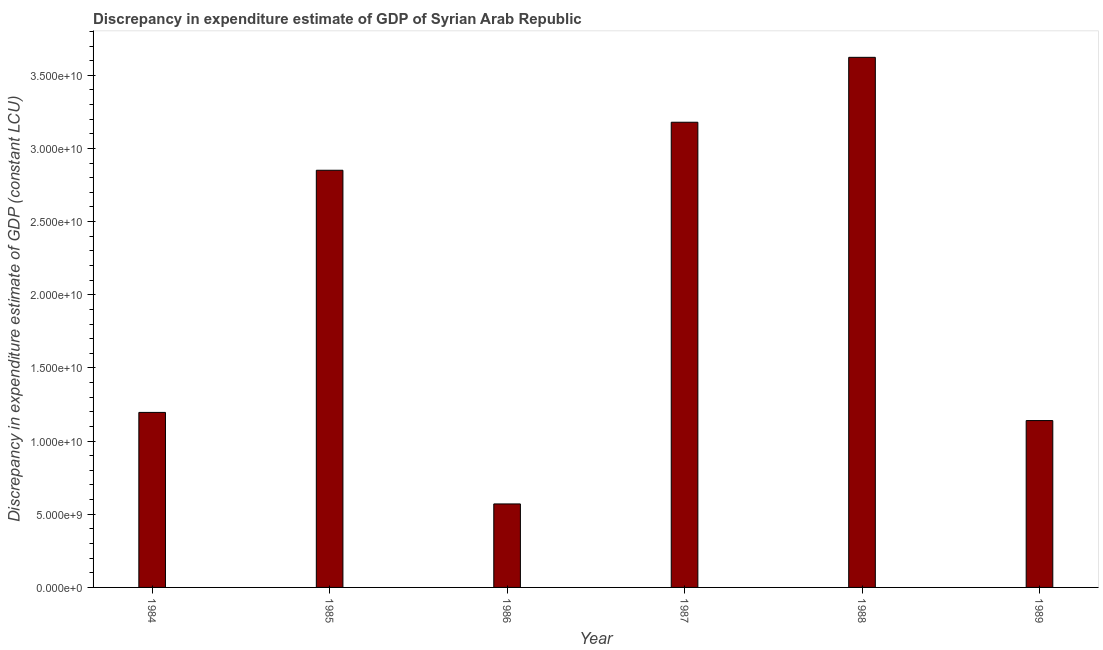Does the graph contain any zero values?
Ensure brevity in your answer.  No. Does the graph contain grids?
Your response must be concise. No. What is the title of the graph?
Ensure brevity in your answer.  Discrepancy in expenditure estimate of GDP of Syrian Arab Republic. What is the label or title of the X-axis?
Make the answer very short. Year. What is the label or title of the Y-axis?
Provide a succinct answer. Discrepancy in expenditure estimate of GDP (constant LCU). What is the discrepancy in expenditure estimate of gdp in 1987?
Your response must be concise. 3.18e+1. Across all years, what is the maximum discrepancy in expenditure estimate of gdp?
Offer a very short reply. 3.62e+1. Across all years, what is the minimum discrepancy in expenditure estimate of gdp?
Provide a short and direct response. 5.71e+09. In which year was the discrepancy in expenditure estimate of gdp minimum?
Keep it short and to the point. 1986. What is the sum of the discrepancy in expenditure estimate of gdp?
Provide a short and direct response. 1.26e+11. What is the difference between the discrepancy in expenditure estimate of gdp in 1987 and 1988?
Provide a short and direct response. -4.44e+09. What is the average discrepancy in expenditure estimate of gdp per year?
Your response must be concise. 2.09e+1. What is the median discrepancy in expenditure estimate of gdp?
Provide a short and direct response. 2.02e+1. In how many years, is the discrepancy in expenditure estimate of gdp greater than 30000000000 LCU?
Offer a very short reply. 2. Do a majority of the years between 1986 and 1987 (inclusive) have discrepancy in expenditure estimate of gdp greater than 3000000000 LCU?
Offer a very short reply. Yes. Is the discrepancy in expenditure estimate of gdp in 1987 less than that in 1989?
Keep it short and to the point. No. What is the difference between the highest and the second highest discrepancy in expenditure estimate of gdp?
Provide a succinct answer. 4.44e+09. What is the difference between the highest and the lowest discrepancy in expenditure estimate of gdp?
Keep it short and to the point. 3.05e+1. How many bars are there?
Your response must be concise. 6. Are all the bars in the graph horizontal?
Your response must be concise. No. What is the difference between two consecutive major ticks on the Y-axis?
Offer a very short reply. 5.00e+09. What is the Discrepancy in expenditure estimate of GDP (constant LCU) in 1984?
Your response must be concise. 1.20e+1. What is the Discrepancy in expenditure estimate of GDP (constant LCU) of 1985?
Provide a succinct answer. 2.85e+1. What is the Discrepancy in expenditure estimate of GDP (constant LCU) of 1986?
Make the answer very short. 5.71e+09. What is the Discrepancy in expenditure estimate of GDP (constant LCU) in 1987?
Offer a very short reply. 3.18e+1. What is the Discrepancy in expenditure estimate of GDP (constant LCU) of 1988?
Offer a very short reply. 3.62e+1. What is the Discrepancy in expenditure estimate of GDP (constant LCU) in 1989?
Provide a short and direct response. 1.14e+1. What is the difference between the Discrepancy in expenditure estimate of GDP (constant LCU) in 1984 and 1985?
Make the answer very short. -1.65e+1. What is the difference between the Discrepancy in expenditure estimate of GDP (constant LCU) in 1984 and 1986?
Make the answer very short. 6.25e+09. What is the difference between the Discrepancy in expenditure estimate of GDP (constant LCU) in 1984 and 1987?
Ensure brevity in your answer.  -1.98e+1. What is the difference between the Discrepancy in expenditure estimate of GDP (constant LCU) in 1984 and 1988?
Provide a short and direct response. -2.43e+1. What is the difference between the Discrepancy in expenditure estimate of GDP (constant LCU) in 1984 and 1989?
Your answer should be compact. 5.57e+08. What is the difference between the Discrepancy in expenditure estimate of GDP (constant LCU) in 1985 and 1986?
Give a very brief answer. 2.28e+1. What is the difference between the Discrepancy in expenditure estimate of GDP (constant LCU) in 1985 and 1987?
Keep it short and to the point. -3.28e+09. What is the difference between the Discrepancy in expenditure estimate of GDP (constant LCU) in 1985 and 1988?
Provide a succinct answer. -7.72e+09. What is the difference between the Discrepancy in expenditure estimate of GDP (constant LCU) in 1985 and 1989?
Give a very brief answer. 1.71e+1. What is the difference between the Discrepancy in expenditure estimate of GDP (constant LCU) in 1986 and 1987?
Make the answer very short. -2.61e+1. What is the difference between the Discrepancy in expenditure estimate of GDP (constant LCU) in 1986 and 1988?
Your answer should be compact. -3.05e+1. What is the difference between the Discrepancy in expenditure estimate of GDP (constant LCU) in 1986 and 1989?
Give a very brief answer. -5.70e+09. What is the difference between the Discrepancy in expenditure estimate of GDP (constant LCU) in 1987 and 1988?
Offer a terse response. -4.44e+09. What is the difference between the Discrepancy in expenditure estimate of GDP (constant LCU) in 1987 and 1989?
Provide a short and direct response. 2.04e+1. What is the difference between the Discrepancy in expenditure estimate of GDP (constant LCU) in 1988 and 1989?
Keep it short and to the point. 2.48e+1. What is the ratio of the Discrepancy in expenditure estimate of GDP (constant LCU) in 1984 to that in 1985?
Offer a terse response. 0.42. What is the ratio of the Discrepancy in expenditure estimate of GDP (constant LCU) in 1984 to that in 1986?
Offer a terse response. 2.1. What is the ratio of the Discrepancy in expenditure estimate of GDP (constant LCU) in 1984 to that in 1987?
Keep it short and to the point. 0.38. What is the ratio of the Discrepancy in expenditure estimate of GDP (constant LCU) in 1984 to that in 1988?
Your answer should be compact. 0.33. What is the ratio of the Discrepancy in expenditure estimate of GDP (constant LCU) in 1984 to that in 1989?
Keep it short and to the point. 1.05. What is the ratio of the Discrepancy in expenditure estimate of GDP (constant LCU) in 1985 to that in 1986?
Provide a succinct answer. 5. What is the ratio of the Discrepancy in expenditure estimate of GDP (constant LCU) in 1985 to that in 1987?
Offer a very short reply. 0.9. What is the ratio of the Discrepancy in expenditure estimate of GDP (constant LCU) in 1985 to that in 1988?
Make the answer very short. 0.79. What is the ratio of the Discrepancy in expenditure estimate of GDP (constant LCU) in 1986 to that in 1987?
Make the answer very short. 0.18. What is the ratio of the Discrepancy in expenditure estimate of GDP (constant LCU) in 1986 to that in 1988?
Offer a terse response. 0.16. What is the ratio of the Discrepancy in expenditure estimate of GDP (constant LCU) in 1986 to that in 1989?
Offer a terse response. 0.5. What is the ratio of the Discrepancy in expenditure estimate of GDP (constant LCU) in 1987 to that in 1988?
Ensure brevity in your answer.  0.88. What is the ratio of the Discrepancy in expenditure estimate of GDP (constant LCU) in 1987 to that in 1989?
Offer a terse response. 2.79. What is the ratio of the Discrepancy in expenditure estimate of GDP (constant LCU) in 1988 to that in 1989?
Offer a terse response. 3.18. 